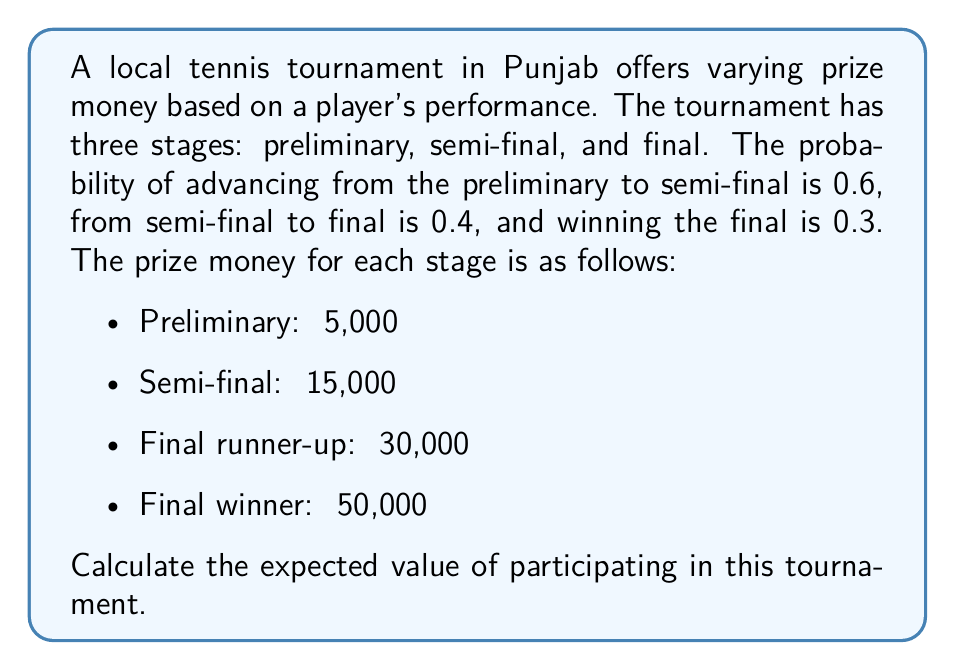Help me with this question. To calculate the expected value, we need to consider all possible outcomes and their associated probabilities and prizes.

1. Probability of only reaching preliminary stage:
   $P(\text{preliminary}) = 1 - 0.6 = 0.4$

2. Probability of reaching semi-final but not final:
   $P(\text{semi-final}) = 0.6 \times (1 - 0.4) = 0.36$

3. Probability of reaching final and being runner-up:
   $P(\text{runner-up}) = 0.6 \times 0.4 \times (1 - 0.3) = 0.168$

4. Probability of winning the tournament:
   $P(\text{winner}) = 0.6 \times 0.4 \times 0.3 = 0.072$

Now, let's calculate the expected value for each outcome:

1. Preliminary: $E_1 = 0.4 \times ₹5,000 = ₹2,000$
2. Semi-final: $E_2 = 0.36 \times ₹15,000 = ₹5,400$
3. Runner-up: $E_3 = 0.168 \times ₹30,000 = ₹5,040$
4. Winner: $E_4 = 0.072 \times ₹50,000 = ₹3,600$

The total expected value is the sum of these individual expected values:

$$E(\text{total}) = E_1 + E_2 + E_3 + E_4$$
$$E(\text{total}) = ₹2,000 + ₹5,400 + ₹5,040 + ₹3,600 = ₹16,040$$
Answer: The expected value of participating in this tournament is ₹16,040. 